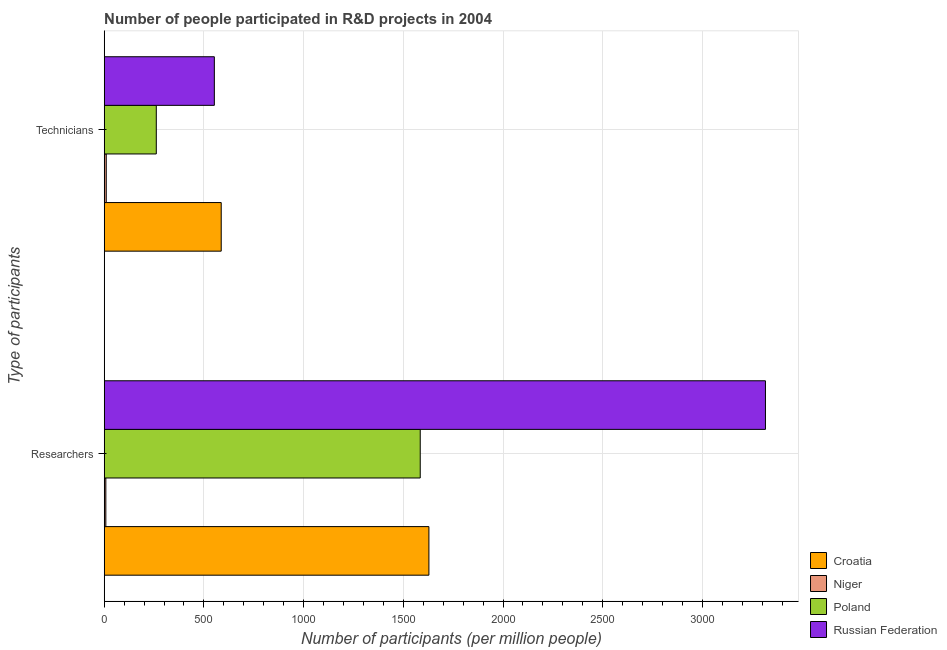How many groups of bars are there?
Offer a terse response. 2. Are the number of bars per tick equal to the number of legend labels?
Ensure brevity in your answer.  Yes. Are the number of bars on each tick of the Y-axis equal?
Offer a very short reply. Yes. What is the label of the 1st group of bars from the top?
Offer a terse response. Technicians. What is the number of technicians in Niger?
Ensure brevity in your answer.  10.23. Across all countries, what is the maximum number of technicians?
Your response must be concise. 586.77. Across all countries, what is the minimum number of researchers?
Your answer should be compact. 8.16. In which country was the number of researchers maximum?
Your response must be concise. Russian Federation. In which country was the number of researchers minimum?
Provide a short and direct response. Niger. What is the total number of researchers in the graph?
Provide a succinct answer. 6537.23. What is the difference between the number of technicians in Niger and that in Poland?
Offer a terse response. -250.96. What is the difference between the number of researchers in Croatia and the number of technicians in Russian Federation?
Offer a terse response. 1075.93. What is the average number of researchers per country?
Your answer should be very brief. 1634.31. What is the difference between the number of technicians and number of researchers in Croatia?
Offer a very short reply. -1041.49. In how many countries, is the number of technicians greater than 1700 ?
Your response must be concise. 0. What is the ratio of the number of technicians in Poland to that in Russian Federation?
Offer a terse response. 0.47. What does the 3rd bar from the top in Researchers represents?
Your answer should be very brief. Niger. What does the 2nd bar from the bottom in Researchers represents?
Your answer should be very brief. Niger. How many bars are there?
Keep it short and to the point. 8. Are all the bars in the graph horizontal?
Your answer should be compact. Yes. How many countries are there in the graph?
Provide a succinct answer. 4. What is the difference between two consecutive major ticks on the X-axis?
Give a very brief answer. 500. Does the graph contain grids?
Offer a very short reply. Yes. Where does the legend appear in the graph?
Your response must be concise. Bottom right. How are the legend labels stacked?
Offer a very short reply. Vertical. What is the title of the graph?
Your response must be concise. Number of people participated in R&D projects in 2004. What is the label or title of the X-axis?
Your answer should be compact. Number of participants (per million people). What is the label or title of the Y-axis?
Your answer should be compact. Type of participants. What is the Number of participants (per million people) of Croatia in Researchers?
Offer a terse response. 1628.26. What is the Number of participants (per million people) in Niger in Researchers?
Provide a short and direct response. 8.16. What is the Number of participants (per million people) in Poland in Researchers?
Provide a short and direct response. 1584.83. What is the Number of participants (per million people) of Russian Federation in Researchers?
Make the answer very short. 3315.98. What is the Number of participants (per million people) in Croatia in Technicians?
Your answer should be very brief. 586.77. What is the Number of participants (per million people) of Niger in Technicians?
Give a very brief answer. 10.23. What is the Number of participants (per million people) in Poland in Technicians?
Make the answer very short. 261.19. What is the Number of participants (per million people) in Russian Federation in Technicians?
Your answer should be very brief. 552.33. Across all Type of participants, what is the maximum Number of participants (per million people) of Croatia?
Your answer should be very brief. 1628.26. Across all Type of participants, what is the maximum Number of participants (per million people) of Niger?
Your answer should be compact. 10.23. Across all Type of participants, what is the maximum Number of participants (per million people) in Poland?
Ensure brevity in your answer.  1584.83. Across all Type of participants, what is the maximum Number of participants (per million people) in Russian Federation?
Give a very brief answer. 3315.98. Across all Type of participants, what is the minimum Number of participants (per million people) in Croatia?
Offer a terse response. 586.77. Across all Type of participants, what is the minimum Number of participants (per million people) in Niger?
Your answer should be very brief. 8.16. Across all Type of participants, what is the minimum Number of participants (per million people) of Poland?
Provide a succinct answer. 261.19. Across all Type of participants, what is the minimum Number of participants (per million people) in Russian Federation?
Give a very brief answer. 552.33. What is the total Number of participants (per million people) in Croatia in the graph?
Your response must be concise. 2215.03. What is the total Number of participants (per million people) of Niger in the graph?
Your answer should be very brief. 18.39. What is the total Number of participants (per million people) in Poland in the graph?
Provide a short and direct response. 1846.02. What is the total Number of participants (per million people) in Russian Federation in the graph?
Ensure brevity in your answer.  3868.31. What is the difference between the Number of participants (per million people) of Croatia in Researchers and that in Technicians?
Make the answer very short. 1041.49. What is the difference between the Number of participants (per million people) of Niger in Researchers and that in Technicians?
Give a very brief answer. -2.08. What is the difference between the Number of participants (per million people) of Poland in Researchers and that in Technicians?
Provide a succinct answer. 1323.64. What is the difference between the Number of participants (per million people) of Russian Federation in Researchers and that in Technicians?
Your answer should be compact. 2763.65. What is the difference between the Number of participants (per million people) of Croatia in Researchers and the Number of participants (per million people) of Niger in Technicians?
Your answer should be compact. 1618.03. What is the difference between the Number of participants (per million people) in Croatia in Researchers and the Number of participants (per million people) in Poland in Technicians?
Make the answer very short. 1367.07. What is the difference between the Number of participants (per million people) of Croatia in Researchers and the Number of participants (per million people) of Russian Federation in Technicians?
Give a very brief answer. 1075.93. What is the difference between the Number of participants (per million people) of Niger in Researchers and the Number of participants (per million people) of Poland in Technicians?
Offer a terse response. -253.04. What is the difference between the Number of participants (per million people) in Niger in Researchers and the Number of participants (per million people) in Russian Federation in Technicians?
Make the answer very short. -544.18. What is the difference between the Number of participants (per million people) in Poland in Researchers and the Number of participants (per million people) in Russian Federation in Technicians?
Your answer should be very brief. 1032.5. What is the average Number of participants (per million people) of Croatia per Type of participants?
Provide a succinct answer. 1107.51. What is the average Number of participants (per million people) in Niger per Type of participants?
Provide a succinct answer. 9.2. What is the average Number of participants (per million people) in Poland per Type of participants?
Your answer should be compact. 923.01. What is the average Number of participants (per million people) of Russian Federation per Type of participants?
Offer a very short reply. 1934.16. What is the difference between the Number of participants (per million people) of Croatia and Number of participants (per million people) of Niger in Researchers?
Your answer should be compact. 1620.11. What is the difference between the Number of participants (per million people) of Croatia and Number of participants (per million people) of Poland in Researchers?
Offer a terse response. 43.43. What is the difference between the Number of participants (per million people) of Croatia and Number of participants (per million people) of Russian Federation in Researchers?
Your response must be concise. -1687.72. What is the difference between the Number of participants (per million people) of Niger and Number of participants (per million people) of Poland in Researchers?
Your answer should be very brief. -1576.68. What is the difference between the Number of participants (per million people) of Niger and Number of participants (per million people) of Russian Federation in Researchers?
Provide a short and direct response. -3307.83. What is the difference between the Number of participants (per million people) of Poland and Number of participants (per million people) of Russian Federation in Researchers?
Make the answer very short. -1731.15. What is the difference between the Number of participants (per million people) of Croatia and Number of participants (per million people) of Niger in Technicians?
Provide a succinct answer. 576.53. What is the difference between the Number of participants (per million people) of Croatia and Number of participants (per million people) of Poland in Technicians?
Provide a succinct answer. 325.58. What is the difference between the Number of participants (per million people) of Croatia and Number of participants (per million people) of Russian Federation in Technicians?
Your answer should be very brief. 34.44. What is the difference between the Number of participants (per million people) in Niger and Number of participants (per million people) in Poland in Technicians?
Offer a terse response. -250.96. What is the difference between the Number of participants (per million people) in Niger and Number of participants (per million people) in Russian Federation in Technicians?
Offer a terse response. -542.1. What is the difference between the Number of participants (per million people) of Poland and Number of participants (per million people) of Russian Federation in Technicians?
Your answer should be compact. -291.14. What is the ratio of the Number of participants (per million people) of Croatia in Researchers to that in Technicians?
Your answer should be very brief. 2.77. What is the ratio of the Number of participants (per million people) in Niger in Researchers to that in Technicians?
Provide a succinct answer. 0.8. What is the ratio of the Number of participants (per million people) in Poland in Researchers to that in Technicians?
Provide a short and direct response. 6.07. What is the ratio of the Number of participants (per million people) in Russian Federation in Researchers to that in Technicians?
Your answer should be compact. 6. What is the difference between the highest and the second highest Number of participants (per million people) of Croatia?
Provide a short and direct response. 1041.49. What is the difference between the highest and the second highest Number of participants (per million people) in Niger?
Ensure brevity in your answer.  2.08. What is the difference between the highest and the second highest Number of participants (per million people) of Poland?
Make the answer very short. 1323.64. What is the difference between the highest and the second highest Number of participants (per million people) of Russian Federation?
Make the answer very short. 2763.65. What is the difference between the highest and the lowest Number of participants (per million people) in Croatia?
Provide a succinct answer. 1041.49. What is the difference between the highest and the lowest Number of participants (per million people) of Niger?
Your response must be concise. 2.08. What is the difference between the highest and the lowest Number of participants (per million people) of Poland?
Keep it short and to the point. 1323.64. What is the difference between the highest and the lowest Number of participants (per million people) in Russian Federation?
Your answer should be very brief. 2763.65. 